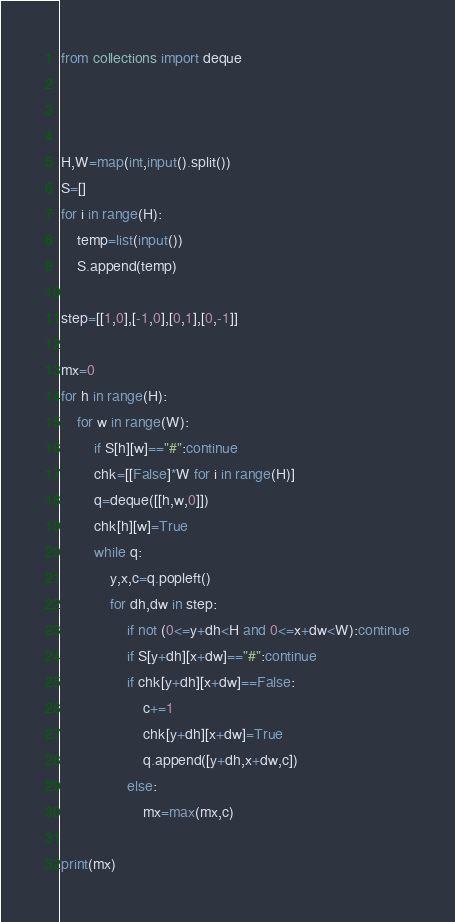Convert code to text. <code><loc_0><loc_0><loc_500><loc_500><_Python_>
from collections import deque



H,W=map(int,input().split())
S=[]
for i in range(H):
    temp=list(input())
    S.append(temp)

step=[[1,0],[-1,0],[0,1],[0,-1]]

mx=0
for h in range(H):
    for w in range(W):
        if S[h][w]=="#":continue
        chk=[[False]*W for i in range(H)]
        q=deque([[h,w,0]])
        chk[h][w]=True
        while q:
            y,x,c=q.popleft()
            for dh,dw in step:
                if not (0<=y+dh<H and 0<=x+dw<W):continue
                if S[y+dh][x+dw]=="#":continue
                if chk[y+dh][x+dw]==False:
                    c+=1
                    chk[y+dh][x+dw]=True
                    q.append([y+dh,x+dw,c])
                else:
                    mx=max(mx,c)

print(mx)


</code> 